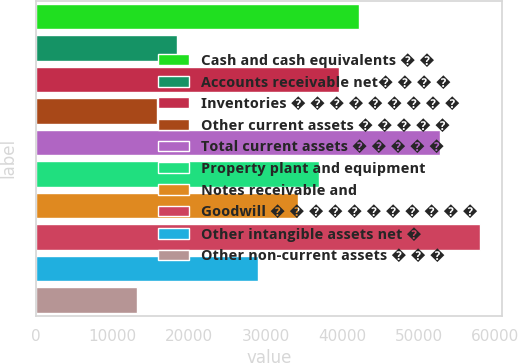Convert chart to OTSL. <chart><loc_0><loc_0><loc_500><loc_500><bar_chart><fcel>Cash and cash equivalents � �<fcel>Accounts receivable net� � � �<fcel>Inventories � � � � � � � � �<fcel>Other current assets � � � � �<fcel>Total current assets � � � � �<fcel>Property plant and equipment<fcel>Notes receivable and<fcel>Goodwill � � � � � � � � � � �<fcel>Other intangible assets net �<fcel>Other non-current assets � � �<nl><fcel>42190.2<fcel>18459.9<fcel>39553.5<fcel>15823.2<fcel>52737<fcel>36916.8<fcel>34280.1<fcel>58010.4<fcel>29006.7<fcel>13186.5<nl></chart> 